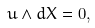<formula> <loc_0><loc_0><loc_500><loc_500>u \wedge d X = 0 ,</formula> 